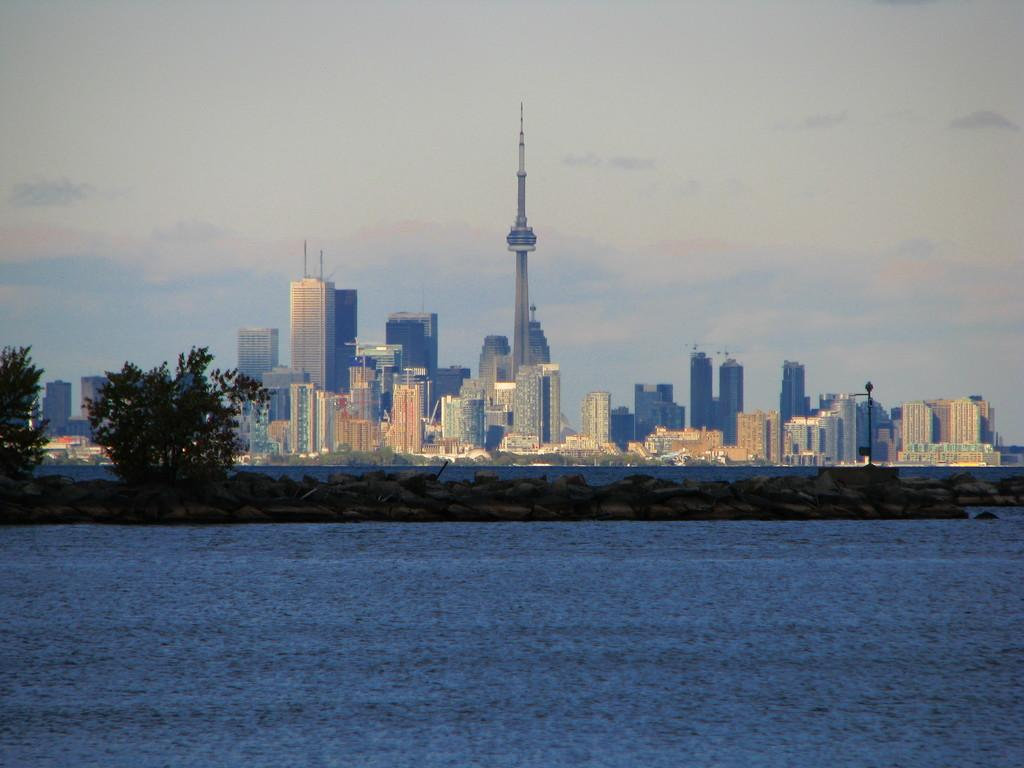What type of natural feature is at the bottom of the image? There is a river at the bottom of the image. What can be seen in the center of the image? There are trees and grass in the center of the image. What type of structures are visible in the background of the image? There are buildings and skyscrapers in the background of the image. What is visible at the top of the image? The sky is visible at the top of the image. Can you tell me which route the rod is taking in the image? There is no rod present in the image, so it is not possible to determine a route. 